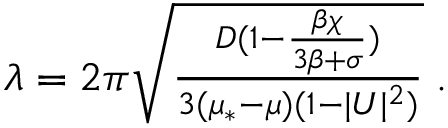Convert formula to latex. <formula><loc_0><loc_0><loc_500><loc_500>\begin{array} { r } { \lambda = 2 \pi \sqrt { \frac { D ( 1 - \frac { \beta \chi } { 3 \beta + \sigma } ) } { 3 ( \mu _ { * } - \mu ) ( 1 - | U | ^ { 2 } ) } } \, . } \end{array}</formula> 